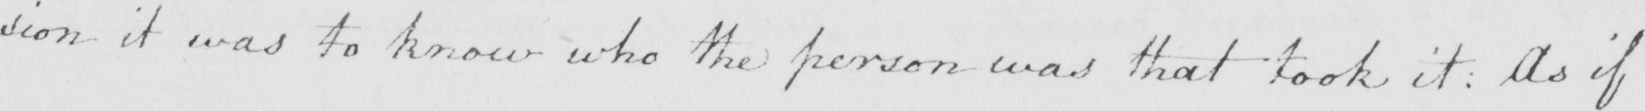Can you read and transcribe this handwriting? : sion it was to know who the person was that took it . As if 